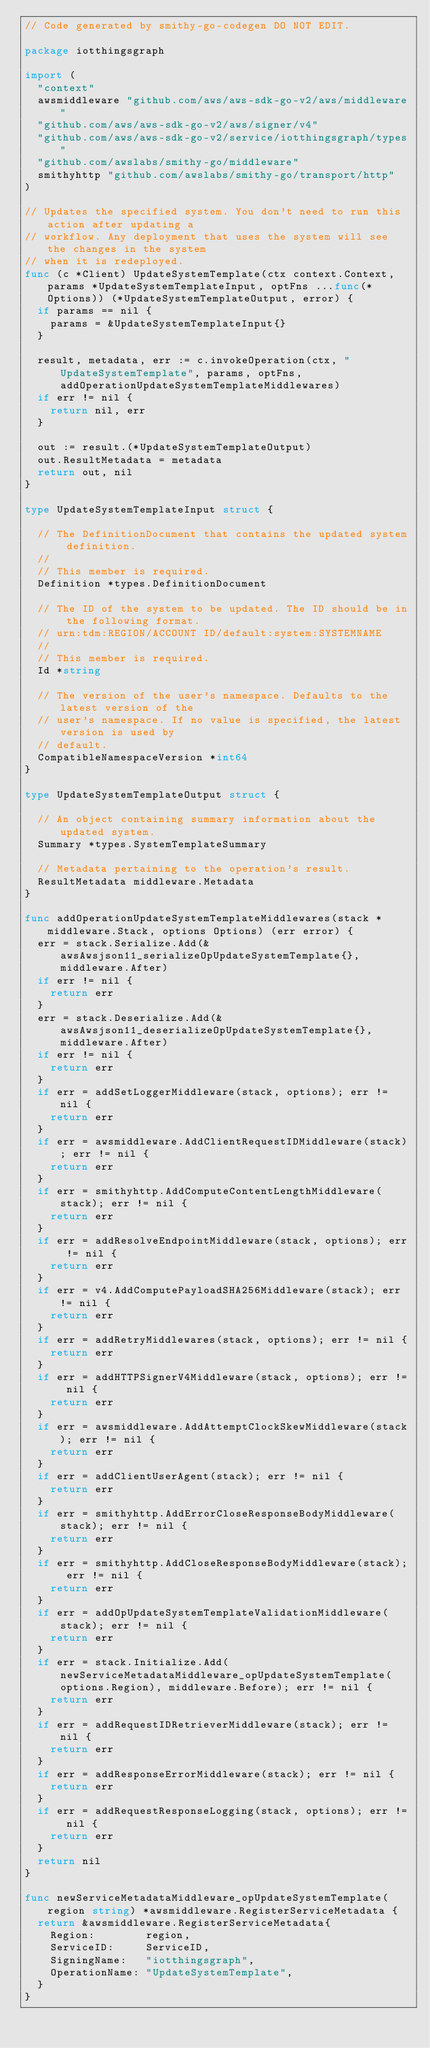Convert code to text. <code><loc_0><loc_0><loc_500><loc_500><_Go_>// Code generated by smithy-go-codegen DO NOT EDIT.

package iotthingsgraph

import (
	"context"
	awsmiddleware "github.com/aws/aws-sdk-go-v2/aws/middleware"
	"github.com/aws/aws-sdk-go-v2/aws/signer/v4"
	"github.com/aws/aws-sdk-go-v2/service/iotthingsgraph/types"
	"github.com/awslabs/smithy-go/middleware"
	smithyhttp "github.com/awslabs/smithy-go/transport/http"
)

// Updates the specified system. You don't need to run this action after updating a
// workflow. Any deployment that uses the system will see the changes in the system
// when it is redeployed.
func (c *Client) UpdateSystemTemplate(ctx context.Context, params *UpdateSystemTemplateInput, optFns ...func(*Options)) (*UpdateSystemTemplateOutput, error) {
	if params == nil {
		params = &UpdateSystemTemplateInput{}
	}

	result, metadata, err := c.invokeOperation(ctx, "UpdateSystemTemplate", params, optFns, addOperationUpdateSystemTemplateMiddlewares)
	if err != nil {
		return nil, err
	}

	out := result.(*UpdateSystemTemplateOutput)
	out.ResultMetadata = metadata
	return out, nil
}

type UpdateSystemTemplateInput struct {

	// The DefinitionDocument that contains the updated system definition.
	//
	// This member is required.
	Definition *types.DefinitionDocument

	// The ID of the system to be updated. The ID should be in the following format.
	// urn:tdm:REGION/ACCOUNT ID/default:system:SYSTEMNAME
	//
	// This member is required.
	Id *string

	// The version of the user's namespace. Defaults to the latest version of the
	// user's namespace. If no value is specified, the latest version is used by
	// default.
	CompatibleNamespaceVersion *int64
}

type UpdateSystemTemplateOutput struct {

	// An object containing summary information about the updated system.
	Summary *types.SystemTemplateSummary

	// Metadata pertaining to the operation's result.
	ResultMetadata middleware.Metadata
}

func addOperationUpdateSystemTemplateMiddlewares(stack *middleware.Stack, options Options) (err error) {
	err = stack.Serialize.Add(&awsAwsjson11_serializeOpUpdateSystemTemplate{}, middleware.After)
	if err != nil {
		return err
	}
	err = stack.Deserialize.Add(&awsAwsjson11_deserializeOpUpdateSystemTemplate{}, middleware.After)
	if err != nil {
		return err
	}
	if err = addSetLoggerMiddleware(stack, options); err != nil {
		return err
	}
	if err = awsmiddleware.AddClientRequestIDMiddleware(stack); err != nil {
		return err
	}
	if err = smithyhttp.AddComputeContentLengthMiddleware(stack); err != nil {
		return err
	}
	if err = addResolveEndpointMiddleware(stack, options); err != nil {
		return err
	}
	if err = v4.AddComputePayloadSHA256Middleware(stack); err != nil {
		return err
	}
	if err = addRetryMiddlewares(stack, options); err != nil {
		return err
	}
	if err = addHTTPSignerV4Middleware(stack, options); err != nil {
		return err
	}
	if err = awsmiddleware.AddAttemptClockSkewMiddleware(stack); err != nil {
		return err
	}
	if err = addClientUserAgent(stack); err != nil {
		return err
	}
	if err = smithyhttp.AddErrorCloseResponseBodyMiddleware(stack); err != nil {
		return err
	}
	if err = smithyhttp.AddCloseResponseBodyMiddleware(stack); err != nil {
		return err
	}
	if err = addOpUpdateSystemTemplateValidationMiddleware(stack); err != nil {
		return err
	}
	if err = stack.Initialize.Add(newServiceMetadataMiddleware_opUpdateSystemTemplate(options.Region), middleware.Before); err != nil {
		return err
	}
	if err = addRequestIDRetrieverMiddleware(stack); err != nil {
		return err
	}
	if err = addResponseErrorMiddleware(stack); err != nil {
		return err
	}
	if err = addRequestResponseLogging(stack, options); err != nil {
		return err
	}
	return nil
}

func newServiceMetadataMiddleware_opUpdateSystemTemplate(region string) *awsmiddleware.RegisterServiceMetadata {
	return &awsmiddleware.RegisterServiceMetadata{
		Region:        region,
		ServiceID:     ServiceID,
		SigningName:   "iotthingsgraph",
		OperationName: "UpdateSystemTemplate",
	}
}
</code> 